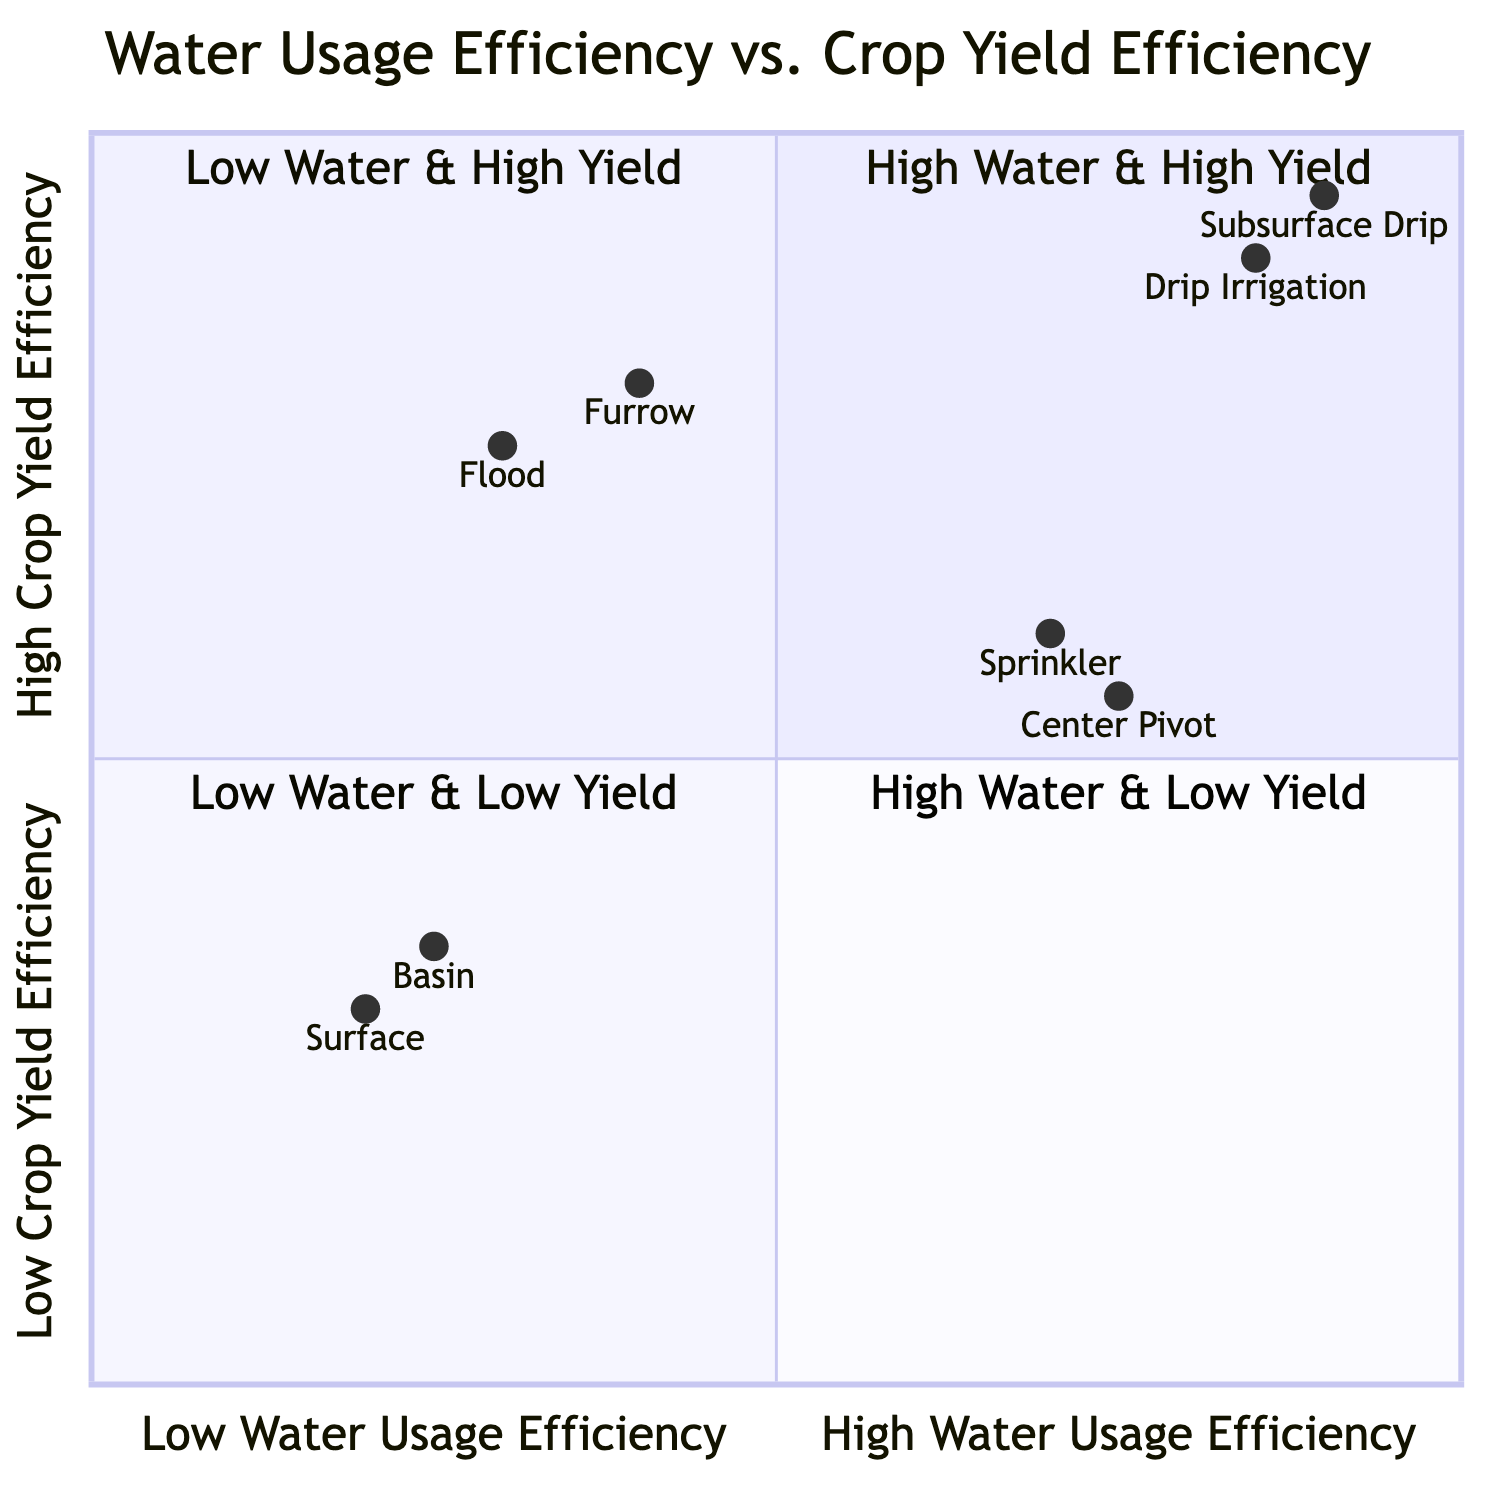What irrigation technique is in the "High Water Usage Efficiency & High Crop Yield Efficiency" quadrant? In the quadrant labeled "High Water Usage Efficiency & High Crop Yield Efficiency," the diagram places two techniques: Drip Irrigation and Subsurface Drip Irrigation. Since the question asks for one, either of these can be considered correct.
Answer: Drip Irrigation How many techniques are in the "Low Water Usage Efficiency & Low Crop Yield Efficiency" quadrant? The "Low Water Usage Efficiency & Low Crop Yield Efficiency" quadrant features two techniques, which are Surface Irrigation and Basin Irrigation. Counting these techniques gives us a total of two.
Answer: 2 Which technique provides the highest crop yield efficiency according to the diagram? Analyzing the quadrants, the "High Water Usage Efficiency & High Crop Yield Efficiency" quadrant indicates the highest crop yield efficiency techniques, specifically Drip Irrigation and Subsurface Drip Irrigation, with crop yield efficiencies of 0.90 and 0.95 respectively. The highest among these is Subsurface Drip Irrigation.
Answer: Subsurface Drip Irrigation What crops are associated with Flood Irrigation? Flood Irrigation is traced to the "Low Water Usage Efficiency & High Crop Yield Efficiency" quadrant, which lists the crops it supports: Rice, Alfalfa, and Pasture Grass.
Answer: Rice, Alfalfa, Pasture Grass What is the crop yield efficiency of Sprinkler Irrigation? Sprinkler Irrigation is located in the "High Water Usage Efficiency & Low Crop Yield Efficiency" quadrant, where its crop yield efficiency is specified as 0.60.
Answer: 0.60 Which quadrant contains techniques that have both low water usage and low crop yield efficiencies? The quadrant labeled "Low Water Usage Efficiency & Low Crop Yield Efficiency" specifically contains the techniques that fit this criterion, which are Surface Irrigation and Basin Irrigation.
Answer: Low Water Usage Efficiency & Low Crop Yield Efficiency Which technique has the highest water usage efficiency in the diagram? Looking at the quadrants, Drip Irrigation has the highest water usage efficiency value listed, which is 0.85. It is grouped in the "High Water Usage Efficiency & High Crop Yield Efficiency" quadrant.
Answer: Drip Irrigation What benefits does Subsurface Drip Irrigation offer? Subsurface Drip Irrigation is noted in the "High Water Usage Efficiency & High Crop Yield Efficiency" quadrant to have benefits such as Precise water delivery and Reduced nutrient leaching.
Answer: Precise water delivery, Reduced nutrient leaching 